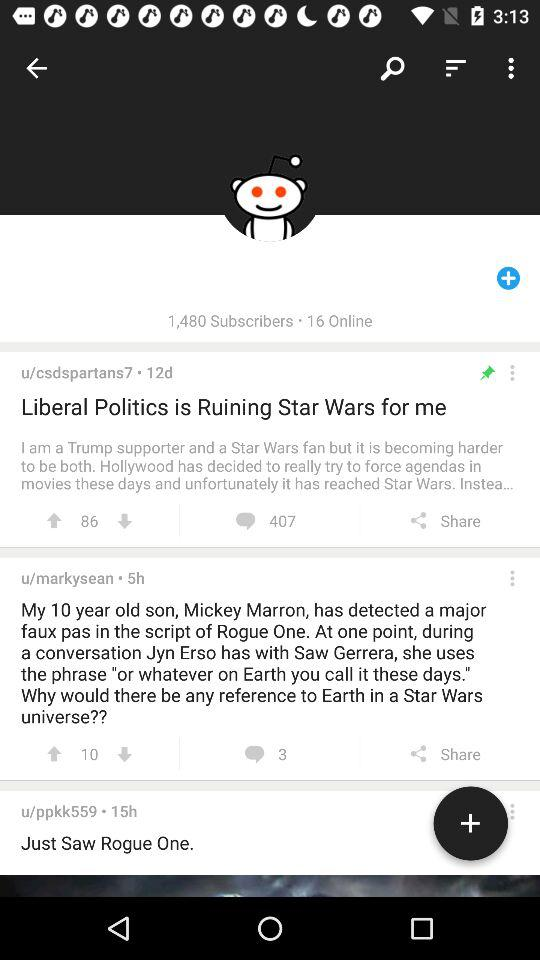How many days ago was the post "Liberal Politics is Ruining Star Wars for me" posted? The post was posted 12 days ago. 